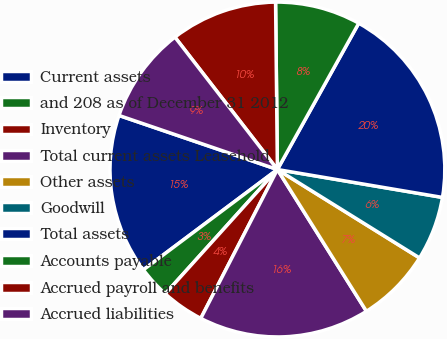Convert chart. <chart><loc_0><loc_0><loc_500><loc_500><pie_chart><fcel>Current assets<fcel>and 208 as of December 31 2012<fcel>Inventory<fcel>Total current assets Leasehold<fcel>Other assets<fcel>Goodwill<fcel>Total assets<fcel>Accounts payable<fcel>Accrued payroll and benefits<fcel>Accrued liabilities<nl><fcel>15.46%<fcel>3.09%<fcel>4.12%<fcel>16.49%<fcel>7.22%<fcel>6.19%<fcel>19.59%<fcel>8.25%<fcel>10.31%<fcel>9.28%<nl></chart> 